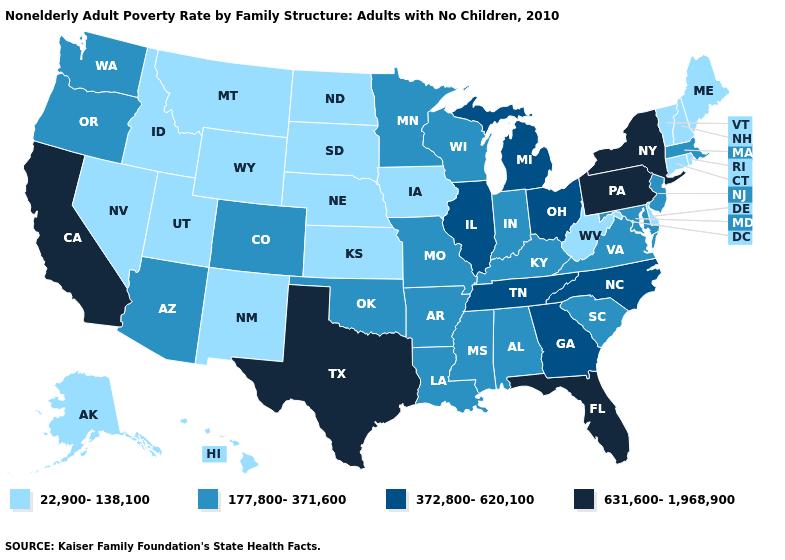Which states hav the highest value in the MidWest?
Quick response, please. Illinois, Michigan, Ohio. Among the states that border Florida , which have the lowest value?
Keep it brief. Alabama. Which states have the lowest value in the USA?
Concise answer only. Alaska, Connecticut, Delaware, Hawaii, Idaho, Iowa, Kansas, Maine, Montana, Nebraska, Nevada, New Hampshire, New Mexico, North Dakota, Rhode Island, South Dakota, Utah, Vermont, West Virginia, Wyoming. Does the map have missing data?
Keep it brief. No. Among the states that border Virginia , which have the lowest value?
Keep it brief. West Virginia. What is the value of Utah?
Quick response, please. 22,900-138,100. What is the value of Texas?
Give a very brief answer. 631,600-1,968,900. Does Hawaii have the lowest value in the USA?
Be succinct. Yes. How many symbols are there in the legend?
Quick response, please. 4. Does Wyoming have the lowest value in the West?
Quick response, please. Yes. Does Delaware have a lower value than Colorado?
Short answer required. Yes. What is the value of Oregon?
Short answer required. 177,800-371,600. What is the value of Indiana?
Answer briefly. 177,800-371,600. Which states have the lowest value in the South?
Concise answer only. Delaware, West Virginia. Does the first symbol in the legend represent the smallest category?
Keep it brief. Yes. 